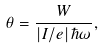<formula> <loc_0><loc_0><loc_500><loc_500>\theta = \frac { W } { \left | I / e \right | \hbar { \omega } } ,</formula> 